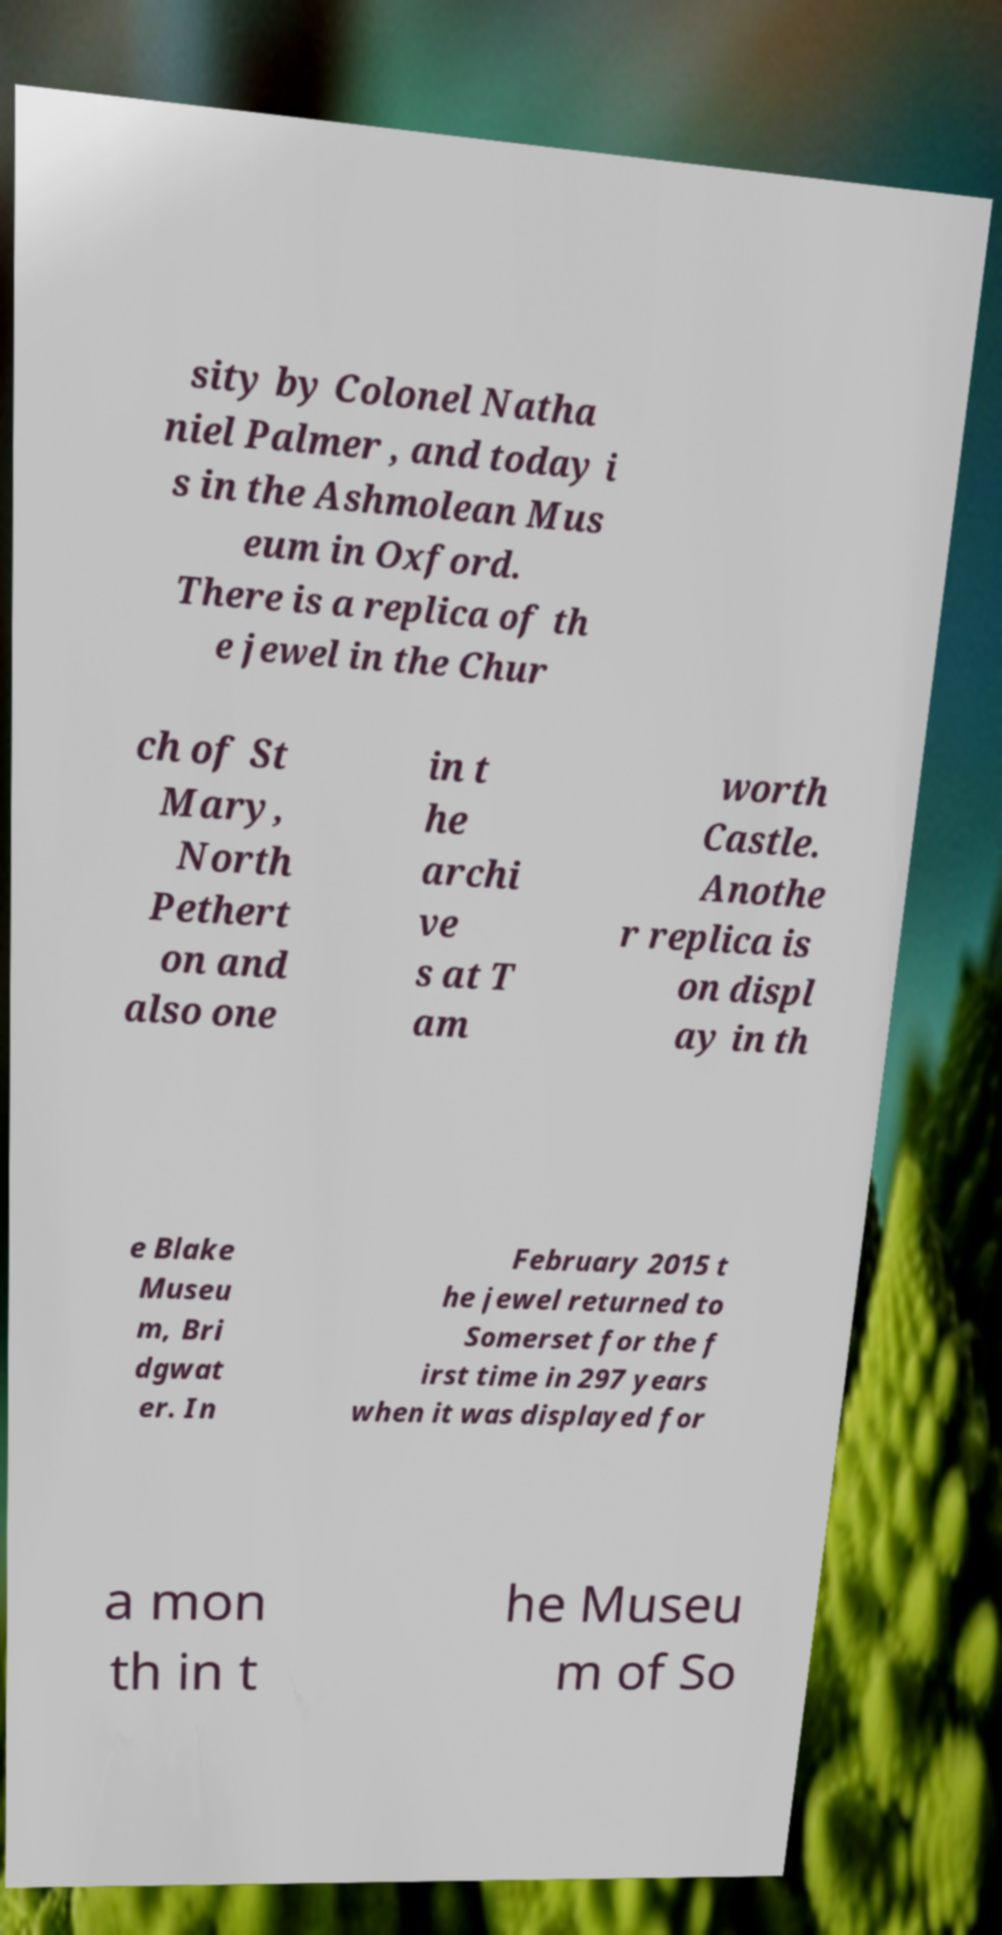Please identify and transcribe the text found in this image. sity by Colonel Natha niel Palmer , and today i s in the Ashmolean Mus eum in Oxford. There is a replica of th e jewel in the Chur ch of St Mary, North Pethert on and also one in t he archi ve s at T am worth Castle. Anothe r replica is on displ ay in th e Blake Museu m, Bri dgwat er. In February 2015 t he jewel returned to Somerset for the f irst time in 297 years when it was displayed for a mon th in t he Museu m of So 